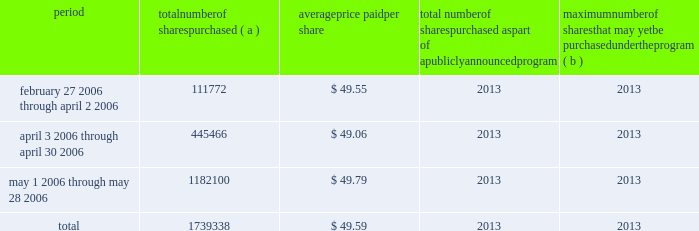2022 reed city , michigan 2022 chanhassen , minnesota 2013 bakeries & foodservice segment 2022 hannibal , missouri 2022 joplin , missouri 2013 bakeries & foodservice segment 2022 vineland , new jersey 2022 albuquerque , new mexico 2022 buffalo , new york 2022 martel , ohio 2013 bakeries & foodservice segment 2022 wellston , ohio 2022 murfreesboro , tennessee 2022 milwaukee , wisconsin we own flour mills at eight locations : vallejo , california ( not currently operating ) ; vernon , california ; avon , iowa ; minneapolis , minnesota ( 2 ) ; kansas city , missouri ; great falls , montana ; and buffalo , new york .
We also operate six terminal grain elevators ( in minnesota and wisconsin , two of which are leased ) , and have country grain elevators in seven locations ( primarily in idaho ) , plus additional seasonal elevators ( primarily in idaho ) .
We also own or lease warehouse space aggregating approximately 12.2 million square feet , of which approxi- mately 9.6 million square feet are leased .
We lease a number of sales and administrative offices in the united states , canada and elsewhere around the world , totaling approxi- mately 2.8 million square feet .
Item 3 legal proceedings we are the subject of various pending or threatened legal actions in the ordinary course of our business .
All such matters are subject to many uncertainties and outcomes that are not predictable with assurance .
In our manage- ment 2019s opinion , there were no claims or litigation pending as of may 28 , 2006 , that are reasonably likely to have a material adverse effect on our consolidated financial posi- tion or results of operations .
Item 4 submission of matters to a vote of security holders part ii item 5 market for registrant 2019s common equity , related stockholder matters and issuer purchases of equity securities our common stock is listed on the new york stock exchange .
On july 14 , 2006 , there were approximately 34675 record holders of our common stock .
Information regarding the market prices for our common stock and dividend payments for the two most recent fiscal years is set forth in note eighteen to the consolidated financial statements on page 53 in item eight of this report .
Infor- mation regarding restrictions on our ability to pay dividends in certain situations is set forth in note eight to the consol- idated financial statements on pages 43 and 44 in item eight of this report .
The table sets forth information with respect to shares of our common stock that we purchased during the three fiscal months ended may 28 , 2006 : issuer purchases of equity securities period number of shares purchased ( a ) average price paid per share total number of shares purchased as part of a publicly announced program maximum number of shares that may yet be purchased under the program ( b ) february 27 , 2006 through april 2 , 2006 111772 $ 49.55 2013 2013 april 3 , 2006 through april 30 , 2006 445466 $ 49.06 2013 2013 may 1 , 2006 through may 28 , 2006 1182100 $ 49.79 2013 2013 .
( a ) the total number of shares purchased includes : ( i ) 231500 shares purchased from the esop fund of our 401 ( k ) savings plan ; ( ii ) 8338 shares of restricted stock withheld for the payment of with- holding taxes upon vesting of restricted stock ; and ( iii ) 1499500 shares purchased in the open market .
( b ) on february 21 , 2000 , we announced that our board of directors autho- rized us to repurchase up to 170 million shares of our common stock to be held in our treasury .
The board did not specify a time period or an expiration date for the authorization. .
What percentage of repurchased stock was purchased in the open market? 
Computations: (1499500 / 1739338)
Answer: 0.86211. 